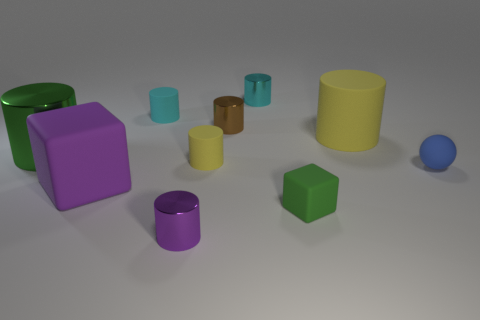There is a thing that is the same color as the small block; what is its size?
Offer a terse response. Large. Does the tiny cylinder left of the small purple cylinder have the same color as the large rubber block?
Your answer should be very brief. No. There is a small rubber cylinder on the right side of the tiny matte thing behind the big shiny cylinder; what number of cubes are to the left of it?
Offer a terse response. 1. How many objects are to the left of the tiny purple cylinder and behind the big yellow object?
Keep it short and to the point. 1. What is the shape of the large shiny object that is the same color as the small rubber block?
Your answer should be compact. Cylinder. Are there any other things that are the same material as the tiny purple cylinder?
Provide a short and direct response. Yes. Is the material of the tiny ball the same as the brown object?
Ensure brevity in your answer.  No. What shape is the small metal thing in front of the purple object behind the small metal cylinder that is in front of the tiny brown metal object?
Ensure brevity in your answer.  Cylinder. Is the number of big rubber blocks that are on the right side of the purple cylinder less than the number of big things that are on the right side of the cyan metal object?
Provide a succinct answer. Yes. What shape is the purple thing behind the metallic thing in front of the blue rubber object?
Give a very brief answer. Cube. 